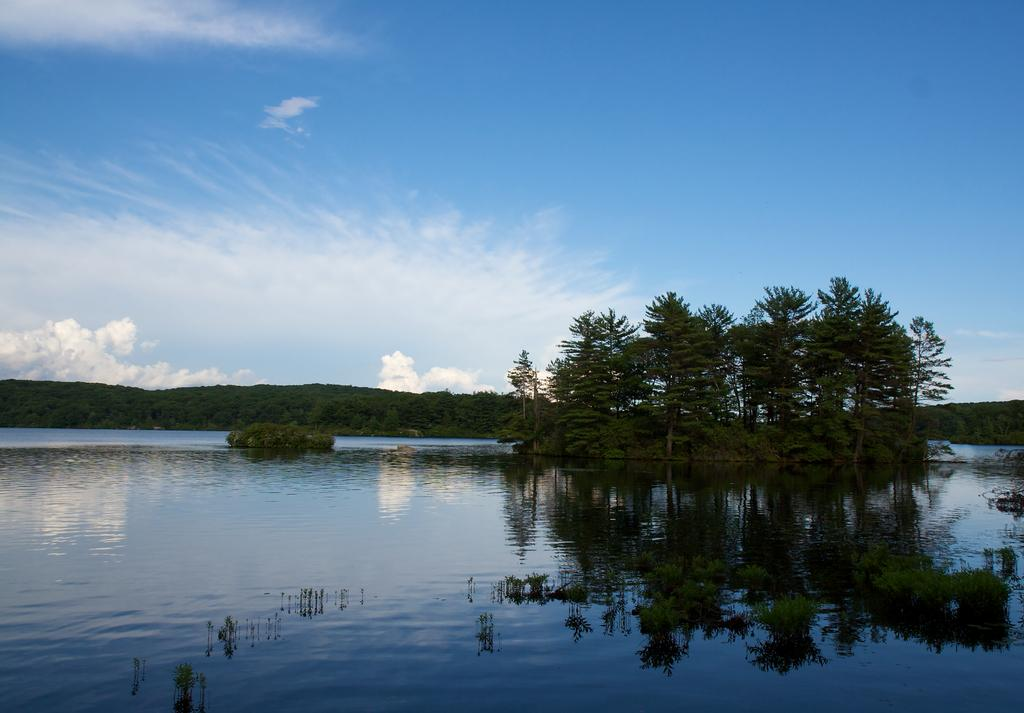What is located on the water in the image? There are trees on the water in the image. What can be seen in the background of the image? The sky is visible in the background of the image. Where is the crate located in the image? There is no crate present in the image. What type of fuel is being used by the trees in the image? Trees do not use fuel, and there are no trees using any type of fuel in the image. 